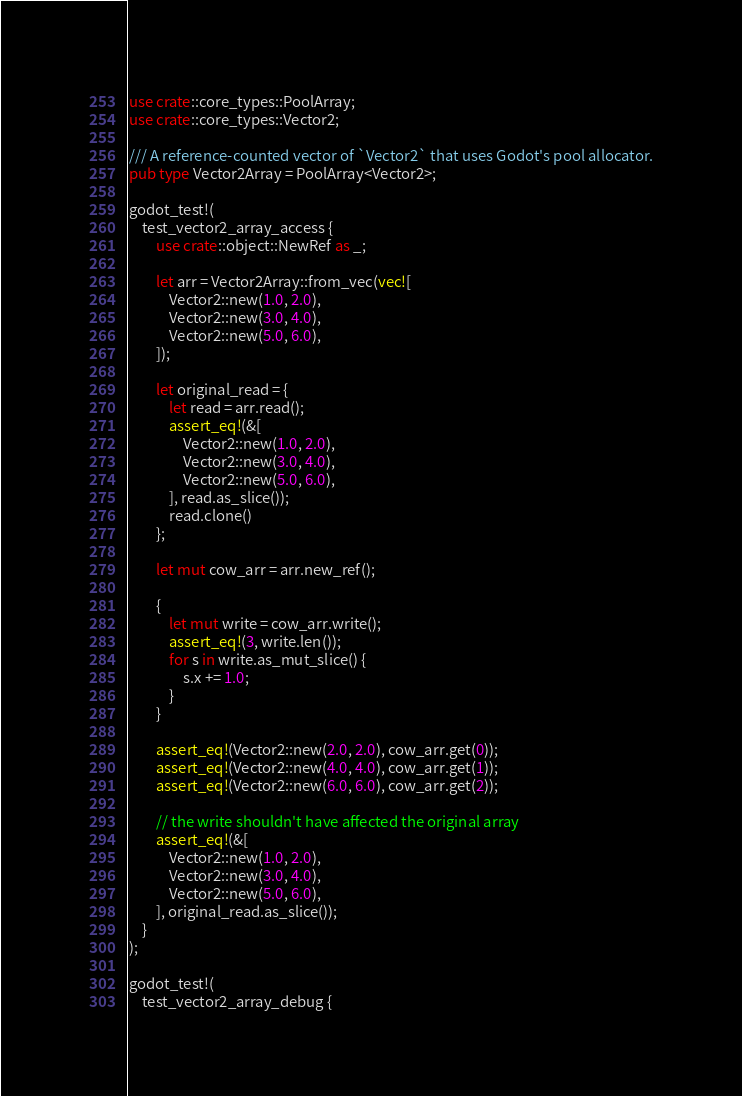<code> <loc_0><loc_0><loc_500><loc_500><_Rust_>use crate::core_types::PoolArray;
use crate::core_types::Vector2;

/// A reference-counted vector of `Vector2` that uses Godot's pool allocator.
pub type Vector2Array = PoolArray<Vector2>;

godot_test!(
    test_vector2_array_access {
        use crate::object::NewRef as _;

        let arr = Vector2Array::from_vec(vec![
            Vector2::new(1.0, 2.0),
            Vector2::new(3.0, 4.0),
            Vector2::new(5.0, 6.0),
        ]);

        let original_read = {
            let read = arr.read();
            assert_eq!(&[
                Vector2::new(1.0, 2.0),
                Vector2::new(3.0, 4.0),
                Vector2::new(5.0, 6.0),
            ], read.as_slice());
            read.clone()
        };

        let mut cow_arr = arr.new_ref();

        {
            let mut write = cow_arr.write();
            assert_eq!(3, write.len());
            for s in write.as_mut_slice() {
                s.x += 1.0;
            }
        }

        assert_eq!(Vector2::new(2.0, 2.0), cow_arr.get(0));
        assert_eq!(Vector2::new(4.0, 4.0), cow_arr.get(1));
        assert_eq!(Vector2::new(6.0, 6.0), cow_arr.get(2));

        // the write shouldn't have affected the original array
        assert_eq!(&[
            Vector2::new(1.0, 2.0),
            Vector2::new(3.0, 4.0),
            Vector2::new(5.0, 6.0),
        ], original_read.as_slice());
    }
);

godot_test!(
    test_vector2_array_debug {</code> 